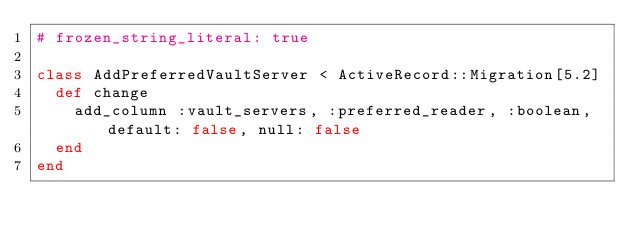Convert code to text. <code><loc_0><loc_0><loc_500><loc_500><_Ruby_># frozen_string_literal: true

class AddPreferredVaultServer < ActiveRecord::Migration[5.2]
  def change
    add_column :vault_servers, :preferred_reader, :boolean, default: false, null: false
  end
end
</code> 